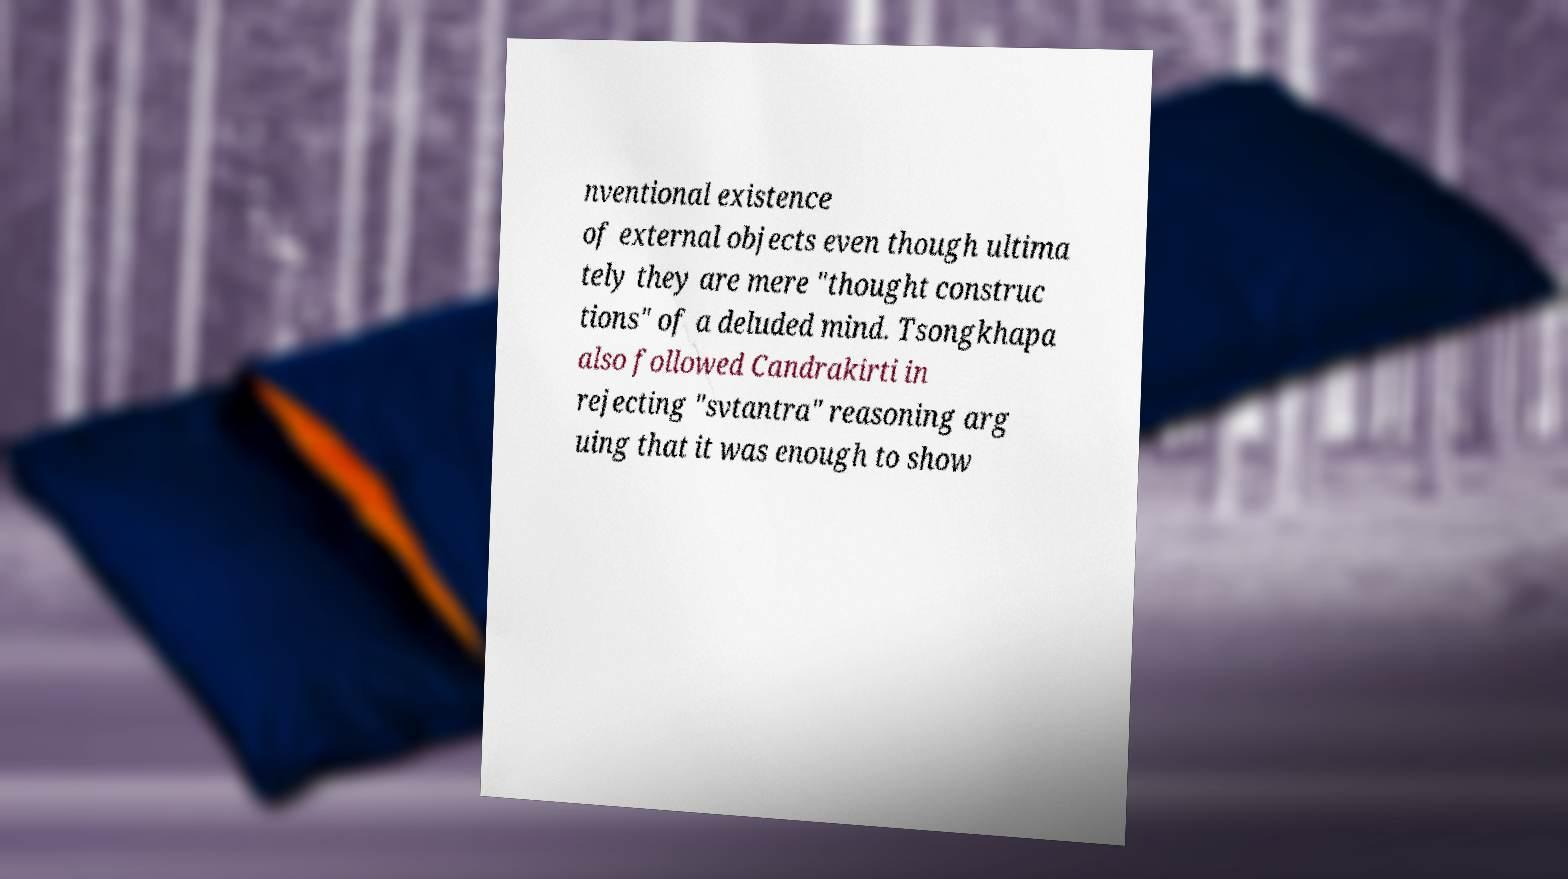Can you read and provide the text displayed in the image?This photo seems to have some interesting text. Can you extract and type it out for me? nventional existence of external objects even though ultima tely they are mere "thought construc tions" of a deluded mind. Tsongkhapa also followed Candrakirti in rejecting "svtantra" reasoning arg uing that it was enough to show 